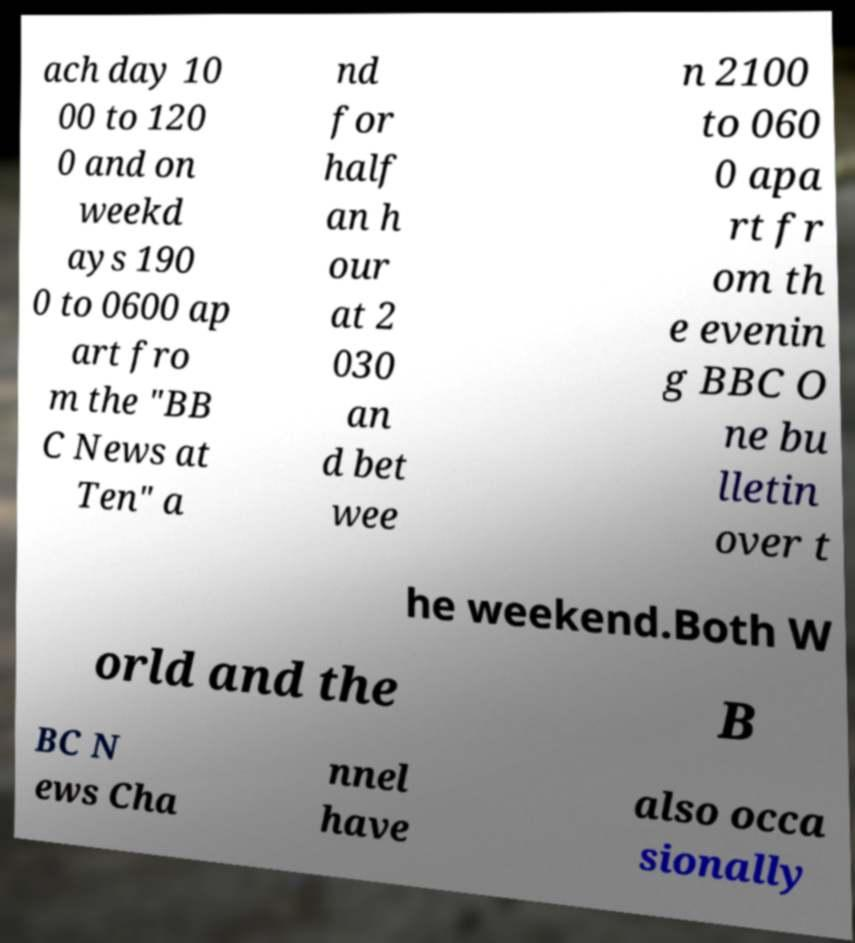For documentation purposes, I need the text within this image transcribed. Could you provide that? ach day 10 00 to 120 0 and on weekd ays 190 0 to 0600 ap art fro m the "BB C News at Ten" a nd for half an h our at 2 030 an d bet wee n 2100 to 060 0 apa rt fr om th e evenin g BBC O ne bu lletin over t he weekend.Both W orld and the B BC N ews Cha nnel have also occa sionally 